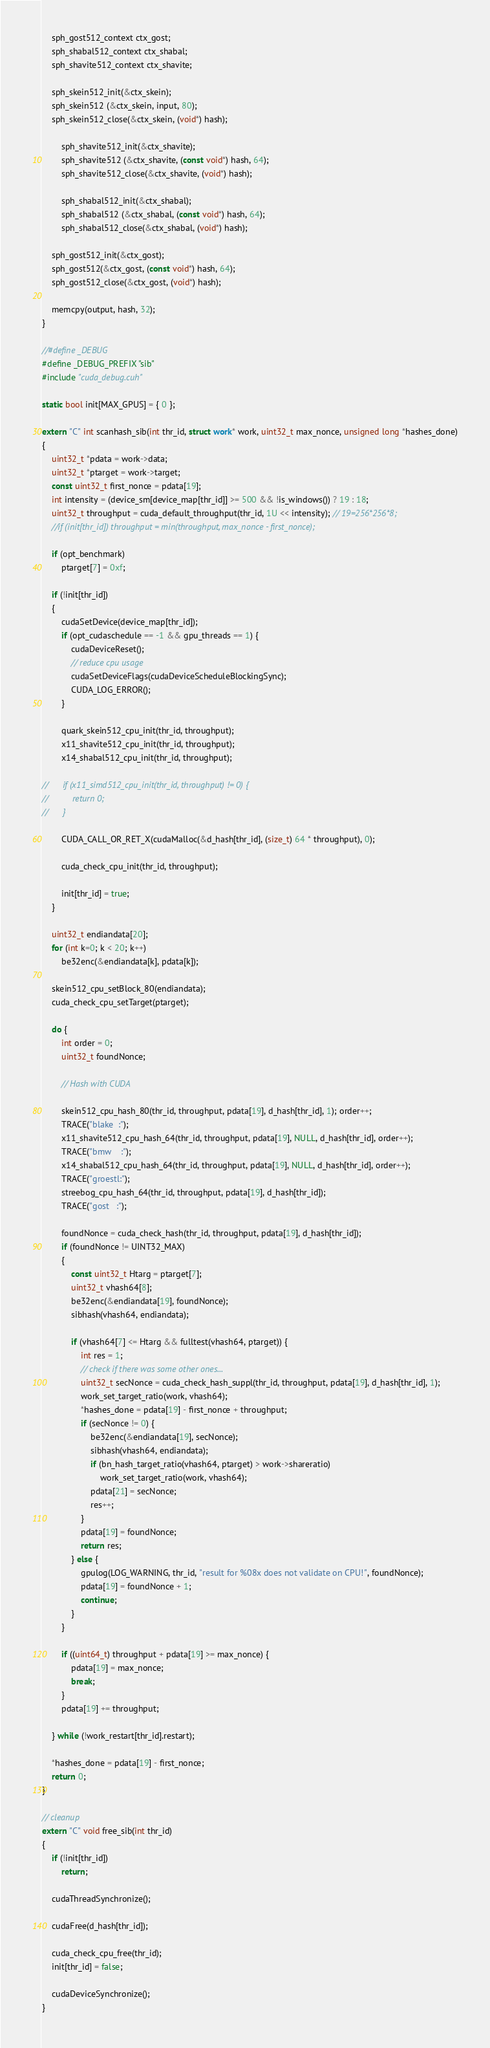<code> <loc_0><loc_0><loc_500><loc_500><_Cuda_>	sph_gost512_context ctx_gost;
	sph_shabal512_context ctx_shabal;
	sph_shavite512_context ctx_shavite;

	sph_skein512_init(&ctx_skein);
	sph_skein512 (&ctx_skein, input, 80);
	sph_skein512_close(&ctx_skein, (void*) hash);

        sph_shavite512_init(&ctx_shavite);
        sph_shavite512 (&ctx_shavite, (const void*) hash, 64);
        sph_shavite512_close(&ctx_shavite, (void*) hash);

        sph_shabal512_init(&ctx_shabal);
        sph_shabal512 (&ctx_shabal, (const void*) hash, 64);
        sph_shabal512_close(&ctx_shabal, (void*) hash);

	sph_gost512_init(&ctx_gost);
	sph_gost512(&ctx_gost, (const void*) hash, 64);
	sph_gost512_close(&ctx_gost, (void*) hash);

	memcpy(output, hash, 32);
}

//#define _DEBUG
#define _DEBUG_PREFIX "sib"
#include "cuda_debug.cuh"

static bool init[MAX_GPUS] = { 0 };

extern "C" int scanhash_sib(int thr_id, struct work* work, uint32_t max_nonce, unsigned long *hashes_done)
{
	uint32_t *pdata = work->data;
	uint32_t *ptarget = work->target;
	const uint32_t first_nonce = pdata[19];
	int intensity = (device_sm[device_map[thr_id]] >= 500 && !is_windows()) ? 19 : 18;
	uint32_t throughput = cuda_default_throughput(thr_id, 1U << intensity); // 19=256*256*8;
	//if (init[thr_id]) throughput = min(throughput, max_nonce - first_nonce);

	if (opt_benchmark)
		ptarget[7] = 0xf;

	if (!init[thr_id])
	{
		cudaSetDevice(device_map[thr_id]);
		if (opt_cudaschedule == -1 && gpu_threads == 1) {
			cudaDeviceReset();
			// reduce cpu usage
			cudaSetDeviceFlags(cudaDeviceScheduleBlockingSync);
			CUDA_LOG_ERROR();
		}

		quark_skein512_cpu_init(thr_id, throughput);
		x11_shavite512_cpu_init(thr_id, throughput);
		x14_shabal512_cpu_init(thr_id, throughput);

//		if (x11_simd512_cpu_init(thr_id, throughput) != 0) {
//			return 0;
//		}

		CUDA_CALL_OR_RET_X(cudaMalloc(&d_hash[thr_id], (size_t) 64 * throughput), 0);

		cuda_check_cpu_init(thr_id, throughput);

		init[thr_id] = true;
	}

	uint32_t endiandata[20];
	for (int k=0; k < 20; k++)
		be32enc(&endiandata[k], pdata[k]);

	skein512_cpu_setBlock_80(endiandata);
	cuda_check_cpu_setTarget(ptarget);

	do {
		int order = 0;
		uint32_t foundNonce;

		// Hash with CUDA
		
		skein512_cpu_hash_80(thr_id, throughput, pdata[19], d_hash[thr_id], 1); order++;
		TRACE("blake  :");
		x11_shavite512_cpu_hash_64(thr_id, throughput, pdata[19], NULL, d_hash[thr_id], order++);
		TRACE("bmw    :");
		x14_shabal512_cpu_hash_64(thr_id, throughput, pdata[19], NULL, d_hash[thr_id], order++);
		TRACE("groestl:");
		streebog_cpu_hash_64(thr_id, throughput, pdata[19], d_hash[thr_id]);
		TRACE("gost   :");

		foundNonce = cuda_check_hash(thr_id, throughput, pdata[19], d_hash[thr_id]);
		if (foundNonce != UINT32_MAX)
		{
			const uint32_t Htarg = ptarget[7];
			uint32_t vhash64[8];
			be32enc(&endiandata[19], foundNonce);
			sibhash(vhash64, endiandata);

			if (vhash64[7] <= Htarg && fulltest(vhash64, ptarget)) {
				int res = 1;
				// check if there was some other ones...
				uint32_t secNonce = cuda_check_hash_suppl(thr_id, throughput, pdata[19], d_hash[thr_id], 1);
				work_set_target_ratio(work, vhash64);
				*hashes_done = pdata[19] - first_nonce + throughput;
				if (secNonce != 0) {
					be32enc(&endiandata[19], secNonce);
					sibhash(vhash64, endiandata);
					if (bn_hash_target_ratio(vhash64, ptarget) > work->shareratio)
						work_set_target_ratio(work, vhash64);
					pdata[21] = secNonce;
					res++;
				}
				pdata[19] = foundNonce;
				return res;
			} else {
				gpulog(LOG_WARNING, thr_id, "result for %08x does not validate on CPU!", foundNonce);
				pdata[19] = foundNonce + 1;
				continue;
			}
		}

		if ((uint64_t) throughput + pdata[19] >= max_nonce) {
			pdata[19] = max_nonce;
			break;
		}
		pdata[19] += throughput;

	} while (!work_restart[thr_id].restart);

	*hashes_done = pdata[19] - first_nonce;
	return 0;
}

// cleanup
extern "C" void free_sib(int thr_id)
{
	if (!init[thr_id])
		return;

	cudaThreadSynchronize();

	cudaFree(d_hash[thr_id]);

	cuda_check_cpu_free(thr_id);
	init[thr_id] = false;

	cudaDeviceSynchronize();
}
</code> 